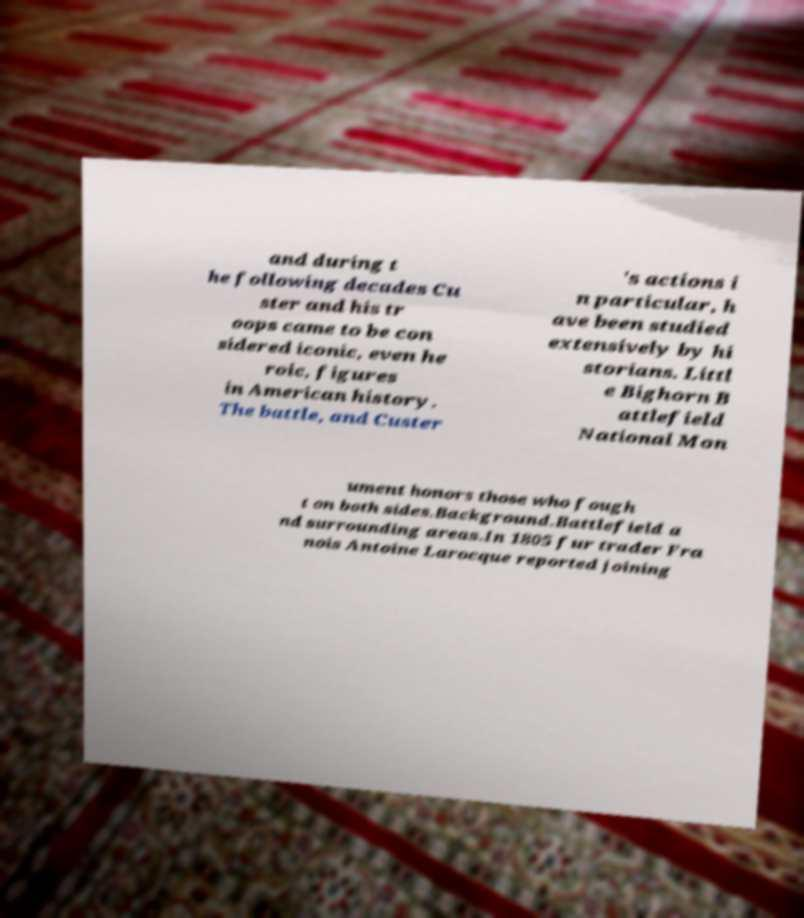What messages or text are displayed in this image? I need them in a readable, typed format. and during t he following decades Cu ster and his tr oops came to be con sidered iconic, even he roic, figures in American history. The battle, and Custer 's actions i n particular, h ave been studied extensively by hi storians. Littl e Bighorn B attlefield National Mon ument honors those who fough t on both sides.Background.Battlefield a nd surrounding areas.In 1805 fur trader Fra nois Antoine Larocque reported joining 